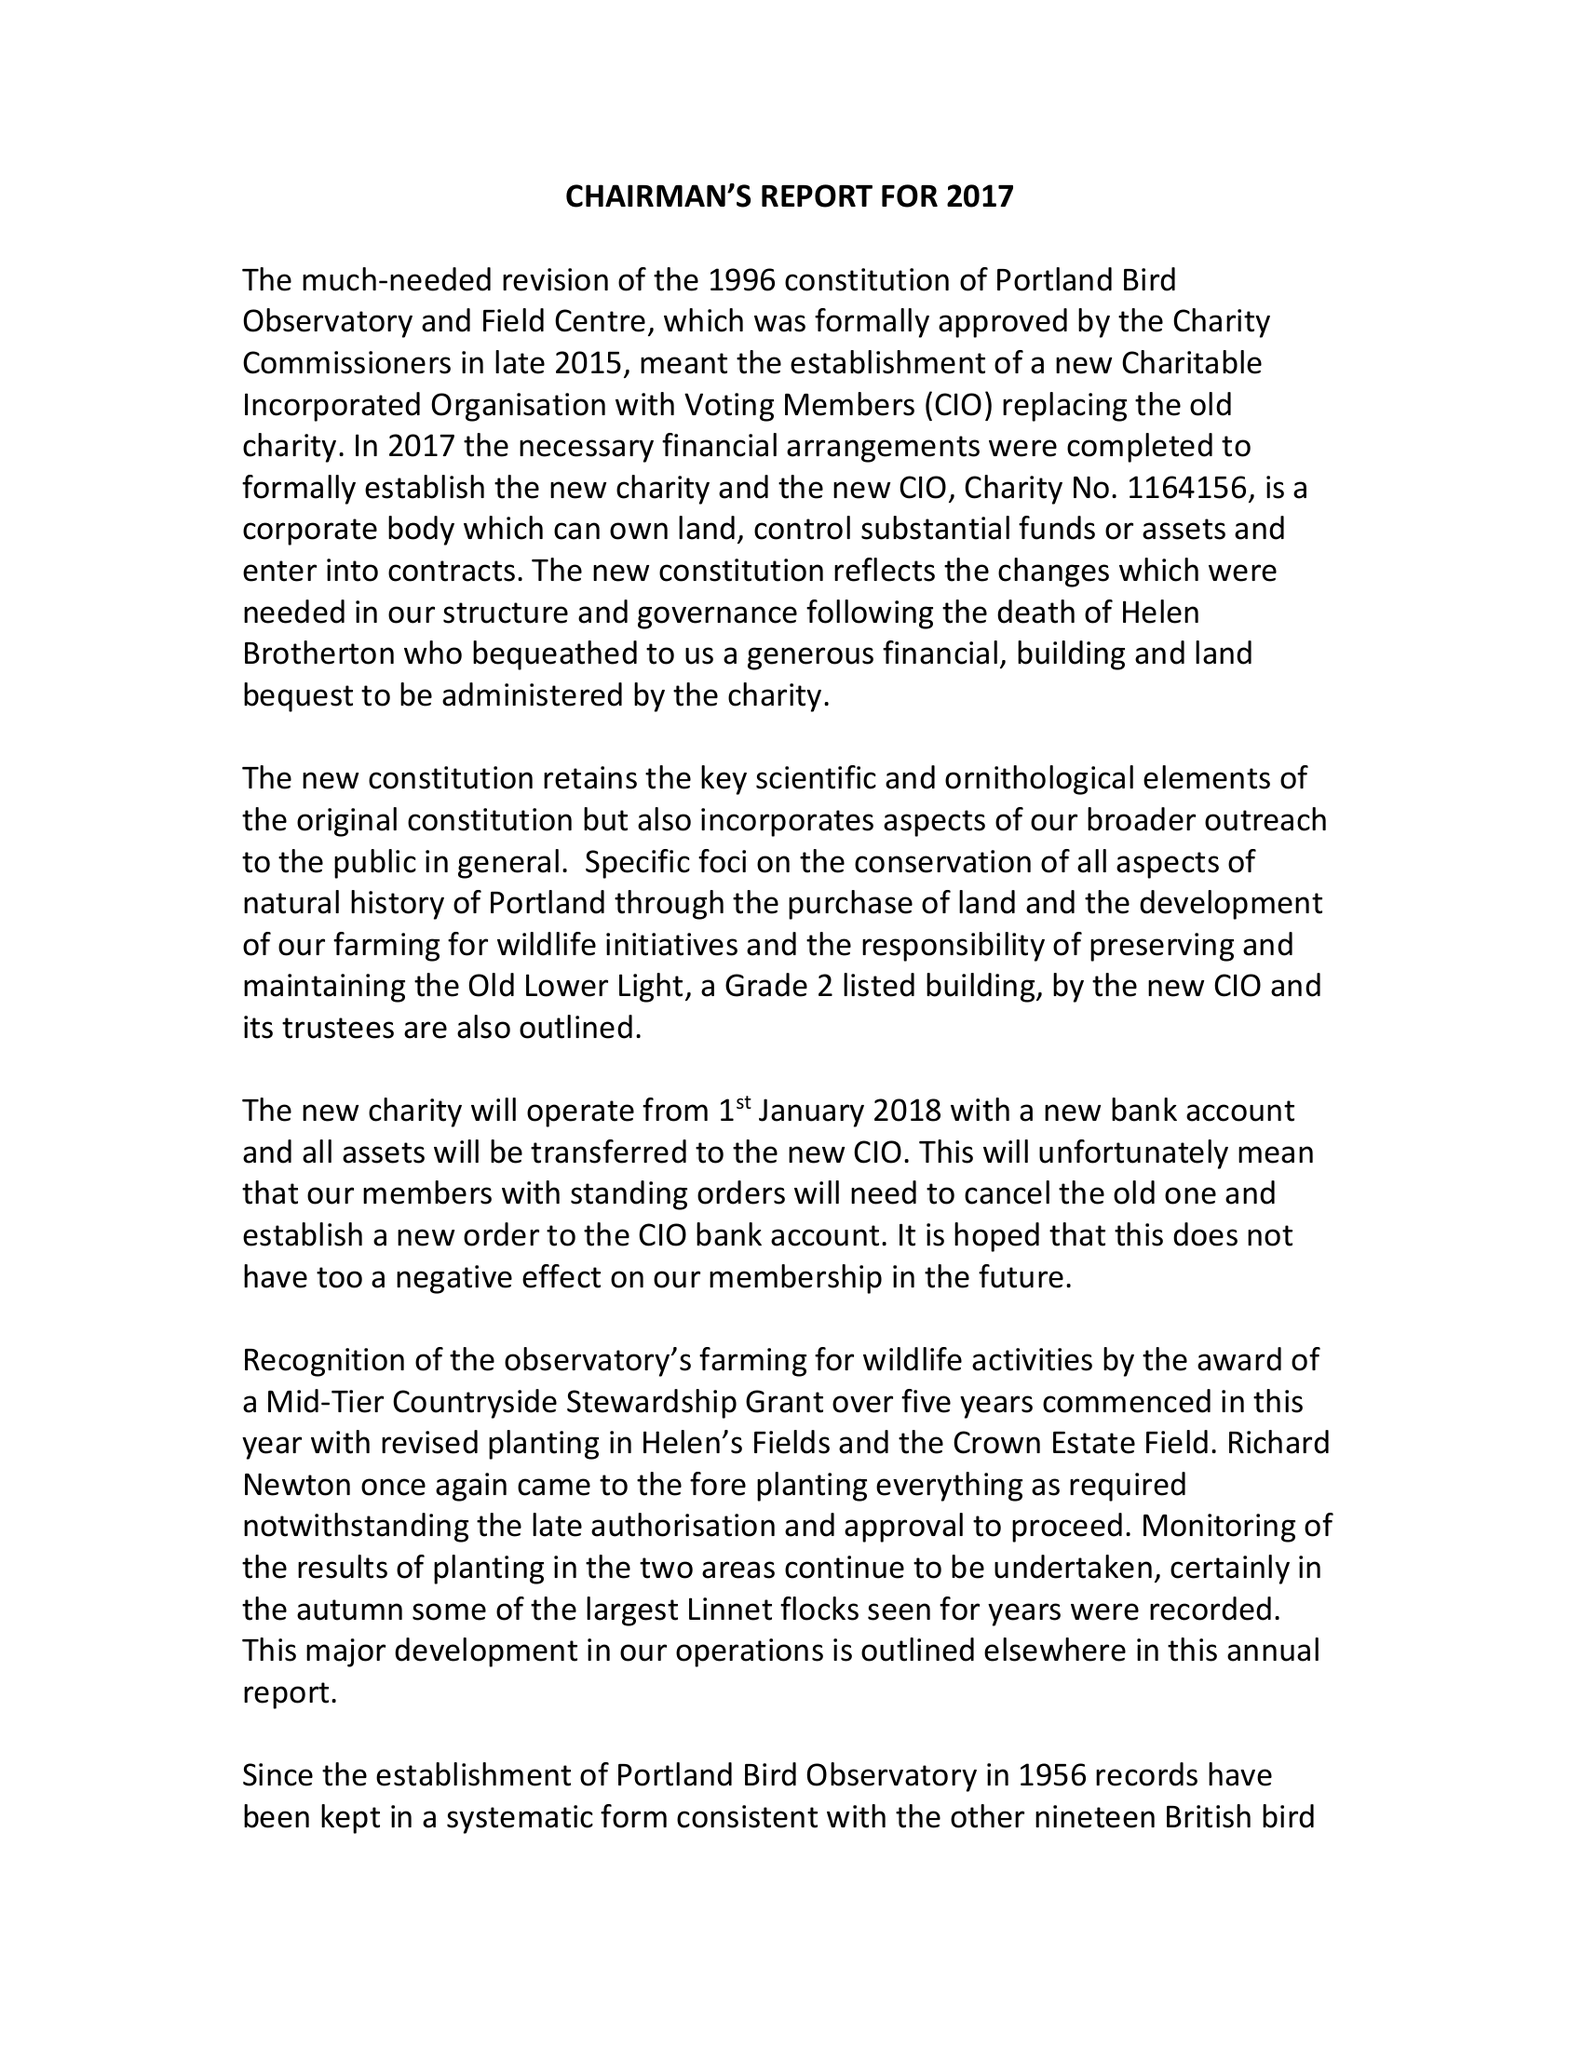What is the value for the address__street_line?
Answer the question using a single word or phrase. None 